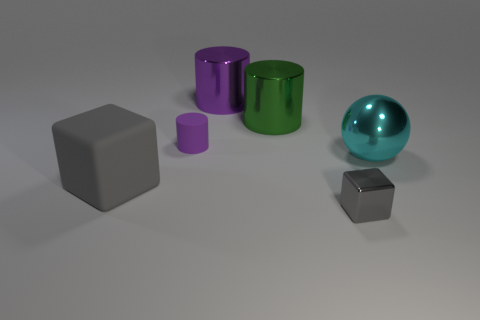What is the material of the tiny thing that is the same color as the big matte object?
Offer a very short reply. Metal. Are there any other things that have the same shape as the large cyan object?
Your response must be concise. No. Are there fewer large cylinders that are in front of the big green cylinder than big cubes?
Make the answer very short. Yes. What is the size of the rubber thing that is behind the large object on the right side of the tiny gray object?
Your answer should be very brief. Small. What number of objects are small shiny blocks or gray blocks?
Offer a terse response. 2. Is there another block that has the same color as the large block?
Ensure brevity in your answer.  Yes. Are there fewer tiny metal blocks than small purple metal blocks?
Make the answer very short. No. What number of objects are either tiny purple objects or cubes on the left side of the metal block?
Your answer should be very brief. 2. Are there any tiny cylinders that have the same material as the big gray cube?
Provide a succinct answer. Yes. What material is the cyan ball that is the same size as the purple metallic object?
Your answer should be compact. Metal. 